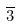Convert formula to latex. <formula><loc_0><loc_0><loc_500><loc_500>\overline { 3 }</formula> 